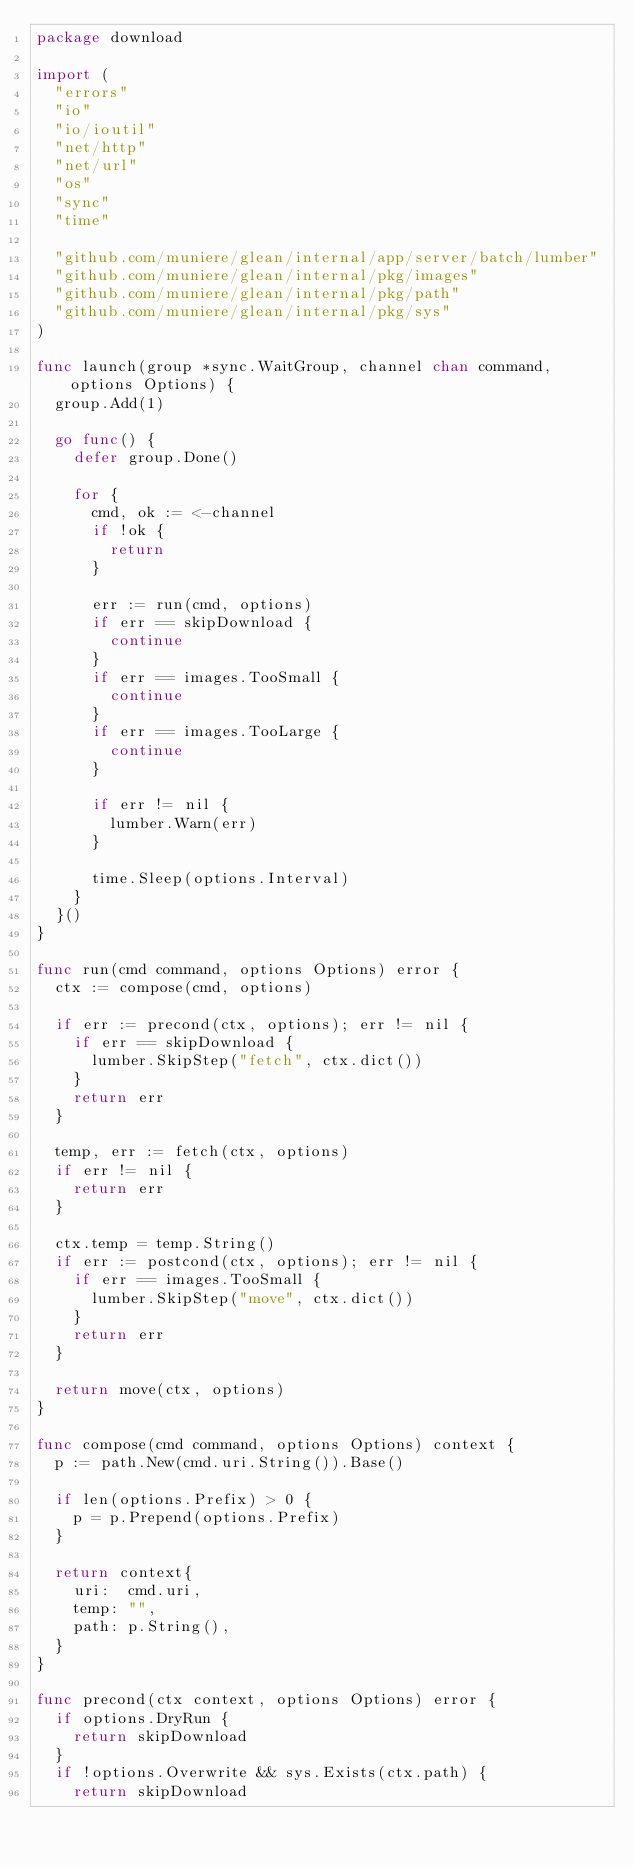<code> <loc_0><loc_0><loc_500><loc_500><_Go_>package download

import (
	"errors"
	"io"
	"io/ioutil"
	"net/http"
	"net/url"
	"os"
	"sync"
	"time"

	"github.com/muniere/glean/internal/app/server/batch/lumber"
	"github.com/muniere/glean/internal/pkg/images"
	"github.com/muniere/glean/internal/pkg/path"
	"github.com/muniere/glean/internal/pkg/sys"
)

func launch(group *sync.WaitGroup, channel chan command, options Options) {
	group.Add(1)

	go func() {
		defer group.Done()

		for {
			cmd, ok := <-channel
			if !ok {
				return
			}

			err := run(cmd, options)
			if err == skipDownload {
				continue
			}
			if err == images.TooSmall {
				continue
			}
			if err == images.TooLarge {
				continue
			}

			if err != nil {
				lumber.Warn(err)
			}

			time.Sleep(options.Interval)
		}
	}()
}

func run(cmd command, options Options) error {
	ctx := compose(cmd, options)

	if err := precond(ctx, options); err != nil {
		if err == skipDownload {
			lumber.SkipStep("fetch", ctx.dict())
		}
		return err
	}

	temp, err := fetch(ctx, options)
	if err != nil {
		return err
	}

	ctx.temp = temp.String()
	if err := postcond(ctx, options); err != nil {
		if err == images.TooSmall {
			lumber.SkipStep("move", ctx.dict())
		}
		return err
	}

	return move(ctx, options)
}

func compose(cmd command, options Options) context {
	p := path.New(cmd.uri.String()).Base()

	if len(options.Prefix) > 0 {
		p = p.Prepend(options.Prefix)
	}

	return context{
		uri:  cmd.uri,
		temp: "",
		path: p.String(),
	}
}

func precond(ctx context, options Options) error {
	if options.DryRun {
		return skipDownload
	}
	if !options.Overwrite && sys.Exists(ctx.path) {
		return skipDownload</code> 